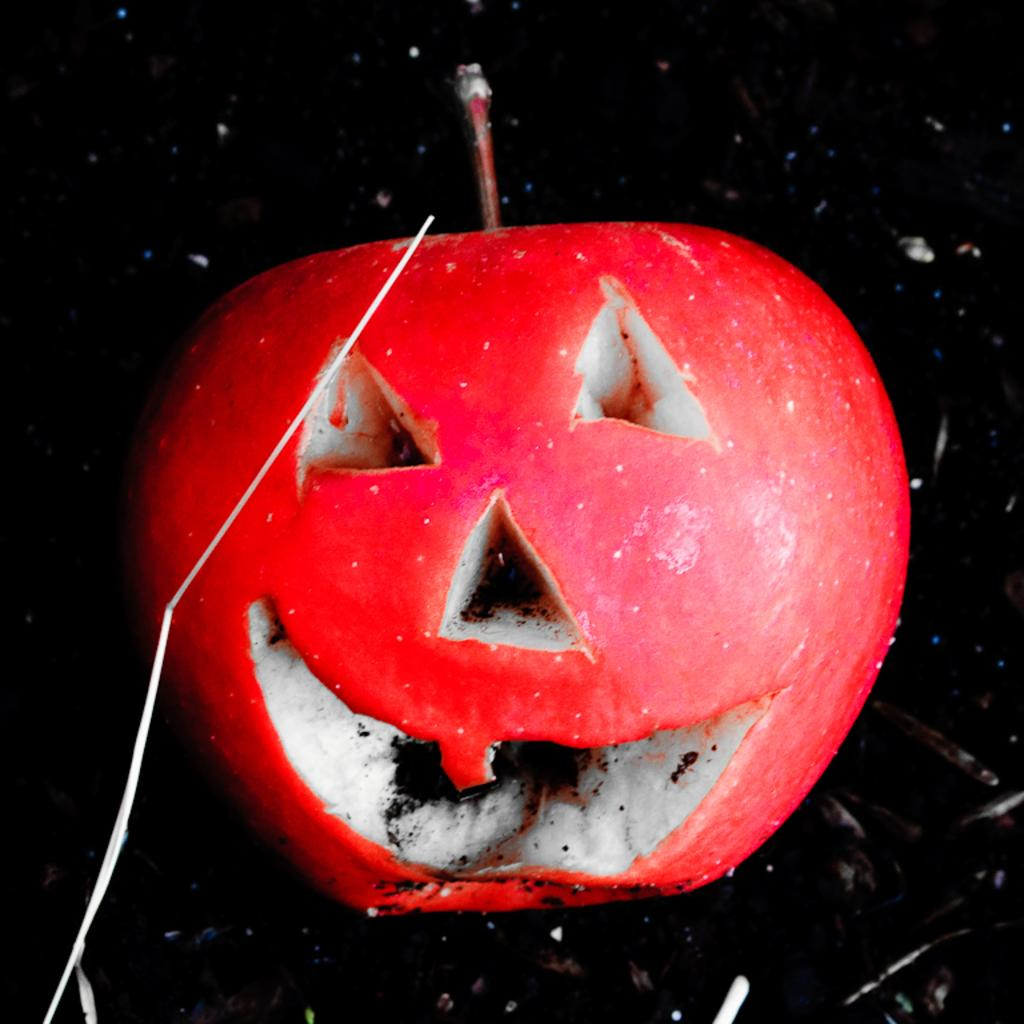What type of fruit is in the image? There is a red color apple in the image. How is the apple shaped? The apple is cut in the shape of a person's face. Where is the apple located in the image? The apple is on the ground. What is the color of the background in the image? The background of the image is dark in color. What type of honey is being served at the dinner in the image? There is no dinner or honey present in the image; it features a cut apple shaped like a person's face on the ground with a dark background. 